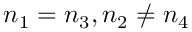Convert formula to latex. <formula><loc_0><loc_0><loc_500><loc_500>n _ { 1 } = n _ { 3 } , n _ { 2 } \neq n _ { 4 }</formula> 